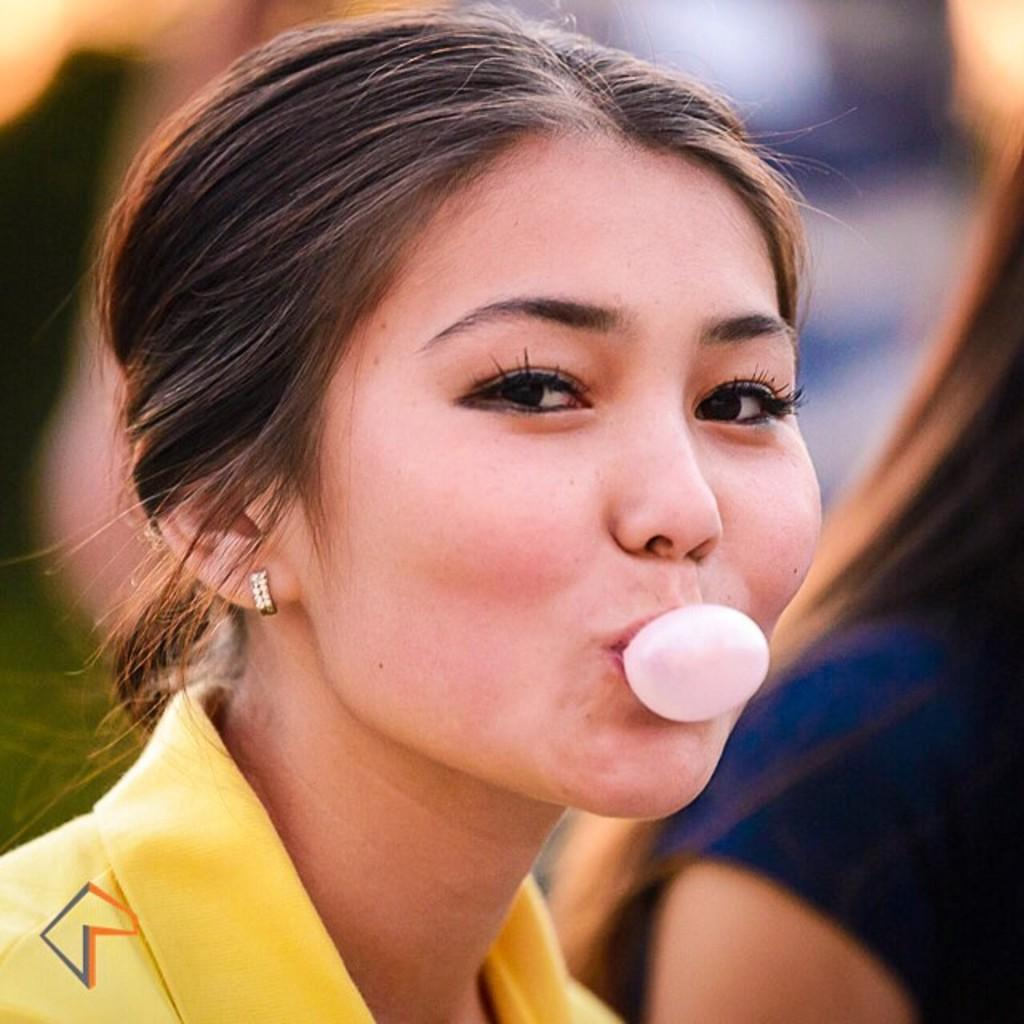What is the woman in the yellow t-shirt doing in the image? The woman in the yellow t-shirt is blowing bubble gum. Can you describe the clothing of the woman in the yellow t-shirt? The woman in the yellow t-shirt is wearing a yellow t-shirt. Are there any other people in the image? Yes, there is another woman in a violet t-shirt in the image. What can be said about the background of the image? The background of the image is blurred. What type of crown is the woman in the yellow t-shirt wearing in the image? There is no crown present in the image; the woman in the yellow t-shirt is blowing bubble gum. What is the woman in the violet t-shirt using to attach the nail to the wall in the image? There is no nail or wall present in the image, and the woman in the violet t-shirt is not shown using any tools or materials. 